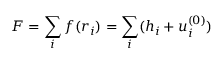Convert formula to latex. <formula><loc_0><loc_0><loc_500><loc_500>F = \sum _ { i } f ( r _ { i } ) = \sum _ { i } ( h _ { i } + u _ { i } ^ { ( 0 ) } )</formula> 